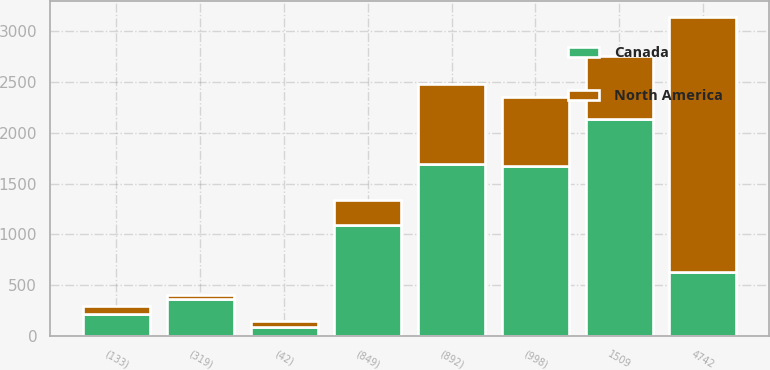Convert chart. <chart><loc_0><loc_0><loc_500><loc_500><stacked_bar_chart><ecel><fcel>4742<fcel>(892)<fcel>(998)<fcel>(133)<fcel>(319)<fcel>(42)<fcel>(849)<fcel>1509<nl><fcel>North America<fcel>2520<fcel>797<fcel>677<fcel>83<fcel>40<fcel>50<fcel>246<fcel>627<nl><fcel>Canada<fcel>627<fcel>1689<fcel>1675<fcel>216<fcel>359<fcel>92<fcel>1095<fcel>2136<nl></chart> 